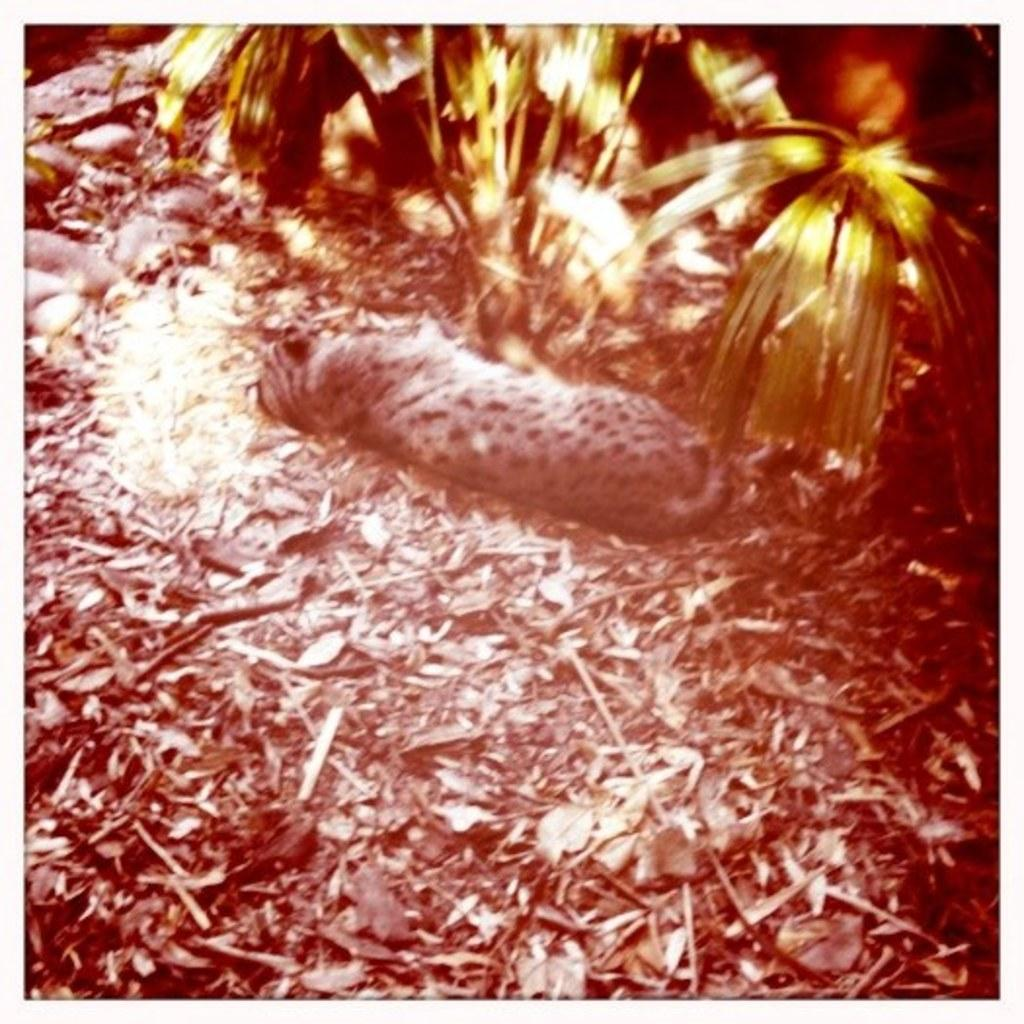What type of creature is in the picture? There is an animal in the picture. What is the animal doing in the image? The animal is sleeping. What is located in front of the animal? There is a plant in front of the animal. What can be seen behind the animal? There are dried leaves behind the animal. What type of flesh can be seen on the animal in the image? There is no flesh visible on the animal in the image, as it is not a part of the picture. 